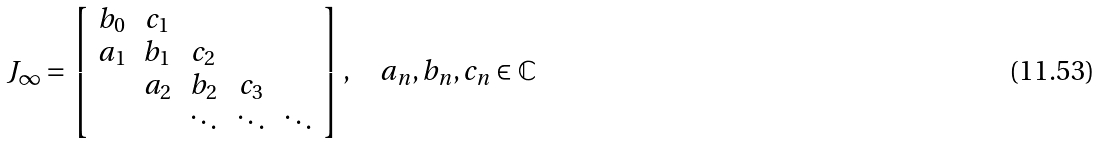Convert formula to latex. <formula><loc_0><loc_0><loc_500><loc_500>J _ { \infty } = \left [ \begin{array} { c c c c c } b _ { 0 } & c _ { 1 } & \\ a _ { 1 } & b _ { 1 } & c _ { 2 } & \\ & a _ { 2 } & b _ { 2 } & c _ { 3 } \\ & & \ddots & \ddots & \ddots \end{array} \right ] , \quad a _ { n } , b _ { n } , c _ { n } \in \mathbb { C }</formula> 